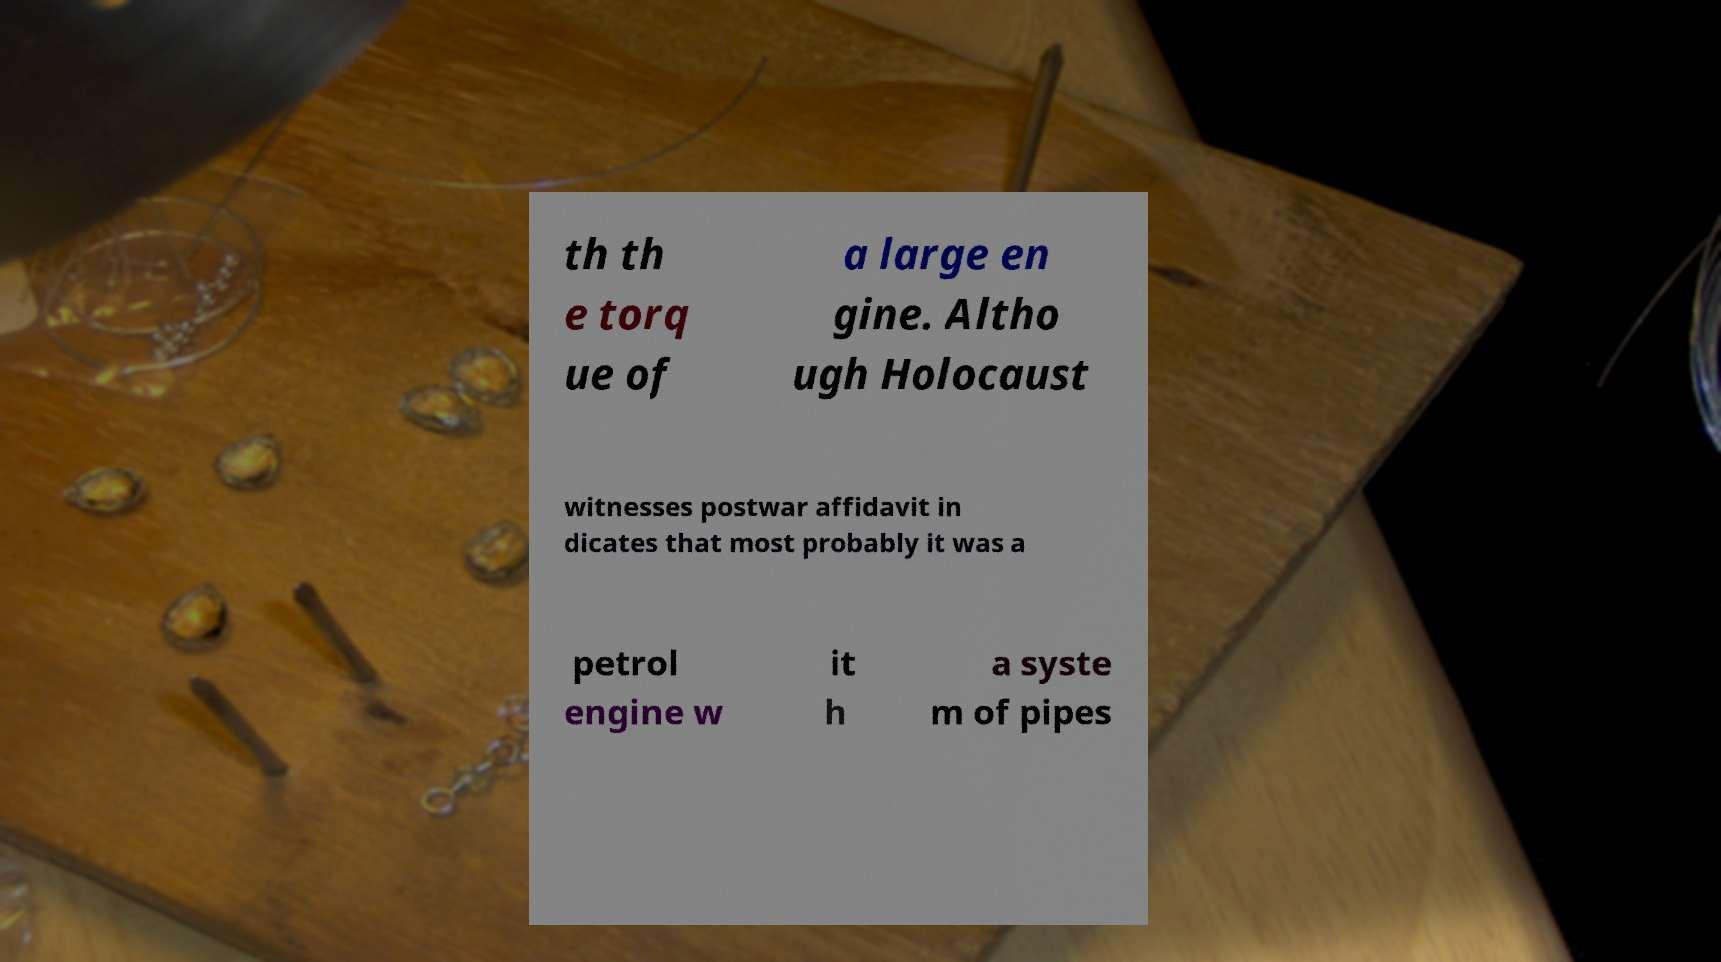Please read and relay the text visible in this image. What does it say? th th e torq ue of a large en gine. Altho ugh Holocaust witnesses postwar affidavit in dicates that most probably it was a petrol engine w it h a syste m of pipes 